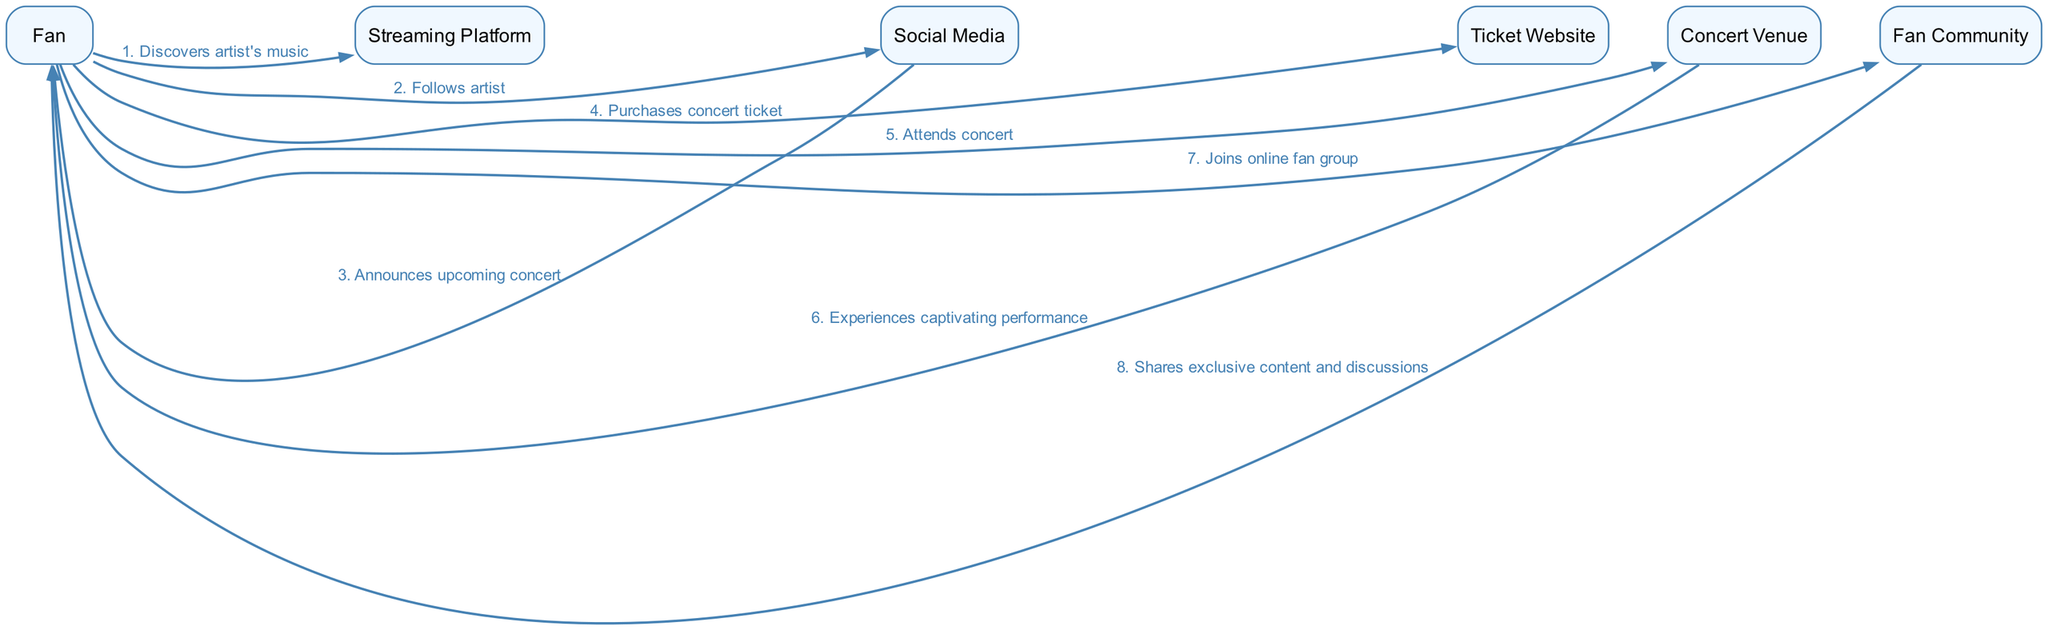What is the first action the fan takes? The first action shown in the sequence is "Discovers artist's music," which is the initial step taken by the fan towards engaging with the artist's work.
Answer: Discovers artist's music How many nodes are there in the diagram? The diagram includes six distinct actors or nodes: Fan, Streaming Platform, Social Media, Ticket Website, Concert Venue, and Fan Community. Counting these gives a total of six nodes.
Answer: 6 What action follows after the fan purchases a concert ticket? According to the sequence, after the fan purchases a concert ticket, the next action is "Attends concert," signifying the fan's participation in the live event.
Answer: Attends concert Which actor shares exclusive content and discussions with the fan? The "Fan Community" is responsible for sharing exclusive content and discussions, enhancing the fan's experience and involvement with the artist and their work.
Answer: Fan Community What is the last action in the sequence? The final action listed is "Shares exclusive content and discussions," indicating the culmination of the fan's journey into becoming part of the community that supports the artist.
Answer: Shares exclusive content and discussions How many actions take place between the fan discovering the artist’s music and attending the concert? There are three actions between discovering the artist's music and attending the concert: "Follows artist," "Announces upcoming concert," and "Purchases concert ticket," which prepares the fan for the concert experience.
Answer: 3 What does the fan experience at the concert venue? The diagram states that the fan "Experiences captivating performance" when they attend the concert at the concert venue, highlighting the emotional and artistic connection during the live show.
Answer: Experiences captivating performance Which two entities are directly connected by the action "Follows artist"? The action "Follows artist" connects the "Fan" and "Social Media" directly, indicating the fan's intention to stay updated on the artist’s activities via social platforms.
Answer: Fan and Social Media What is the relationship between the concert venue and the fan? The relationship is one of experience, as the fan "Attends concert" at the concert venue, which is directly followed by "Experiences captivating performance," indicating a direct interaction.
Answer: Attends concert 